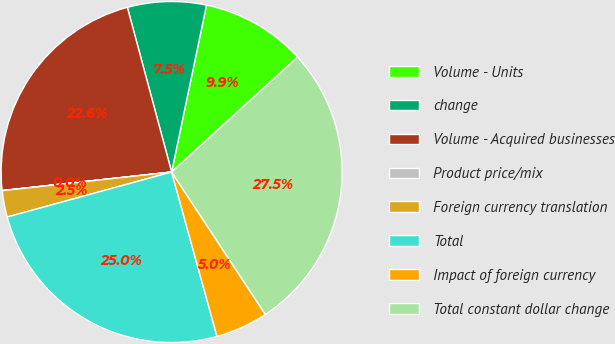Convert chart to OTSL. <chart><loc_0><loc_0><loc_500><loc_500><pie_chart><fcel>Volume - Units<fcel>change<fcel>Volume - Acquired businesses<fcel>Product price/mix<fcel>Foreign currency translation<fcel>Total<fcel>Impact of foreign currency<fcel>Total constant dollar change<nl><fcel>9.94%<fcel>7.46%<fcel>22.55%<fcel>0.02%<fcel>2.5%<fcel>25.03%<fcel>4.98%<fcel>27.51%<nl></chart> 